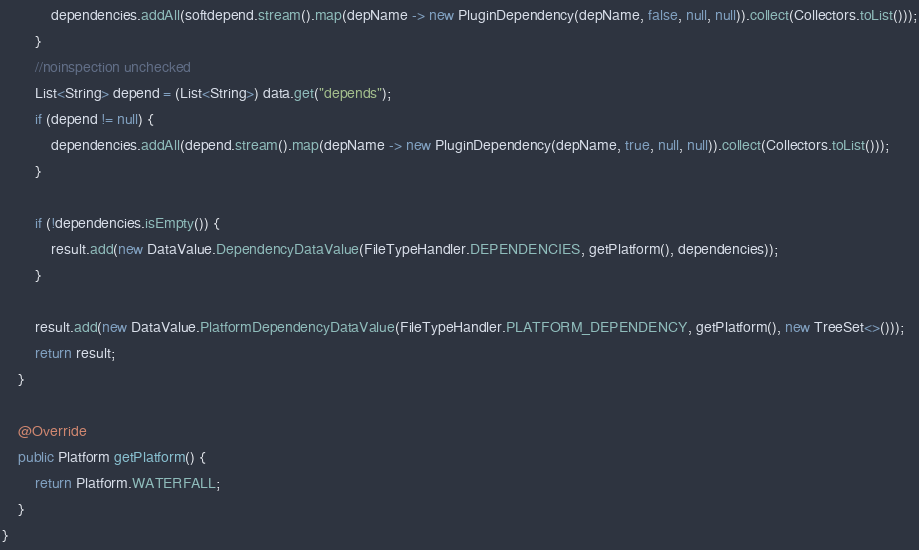<code> <loc_0><loc_0><loc_500><loc_500><_Java_>            dependencies.addAll(softdepend.stream().map(depName -> new PluginDependency(depName, false, null, null)).collect(Collectors.toList()));
        }
        //noinspection unchecked
        List<String> depend = (List<String>) data.get("depends");
        if (depend != null) {
            dependencies.addAll(depend.stream().map(depName -> new PluginDependency(depName, true, null, null)).collect(Collectors.toList()));
        }

        if (!dependencies.isEmpty()) {
            result.add(new DataValue.DependencyDataValue(FileTypeHandler.DEPENDENCIES, getPlatform(), dependencies));
        }

        result.add(new DataValue.PlatformDependencyDataValue(FileTypeHandler.PLATFORM_DEPENDENCY, getPlatform(), new TreeSet<>()));
        return result;
    }

    @Override
    public Platform getPlatform() {
        return Platform.WATERFALL;
    }
}
</code> 